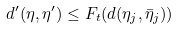<formula> <loc_0><loc_0><loc_500><loc_500>& d ^ { \prime } ( \eta , \eta ^ { \prime } ) \leq F _ { t } ( d ( \eta _ { j } , \bar { \eta } _ { j } ) )</formula> 